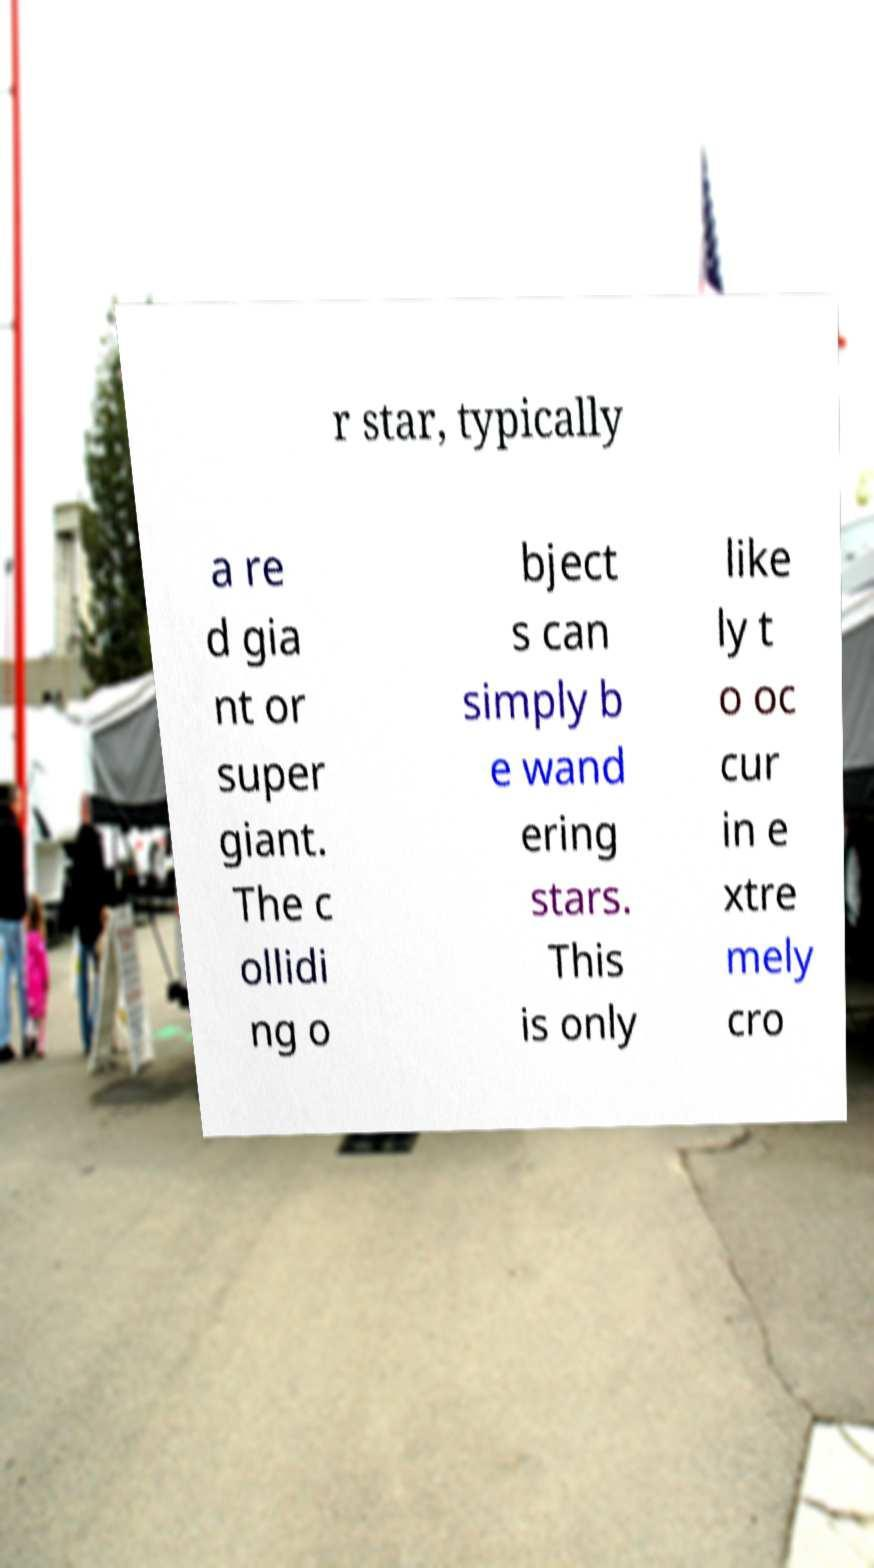There's text embedded in this image that I need extracted. Can you transcribe it verbatim? r star, typically a re d gia nt or super giant. The c ollidi ng o bject s can simply b e wand ering stars. This is only like ly t o oc cur in e xtre mely cro 